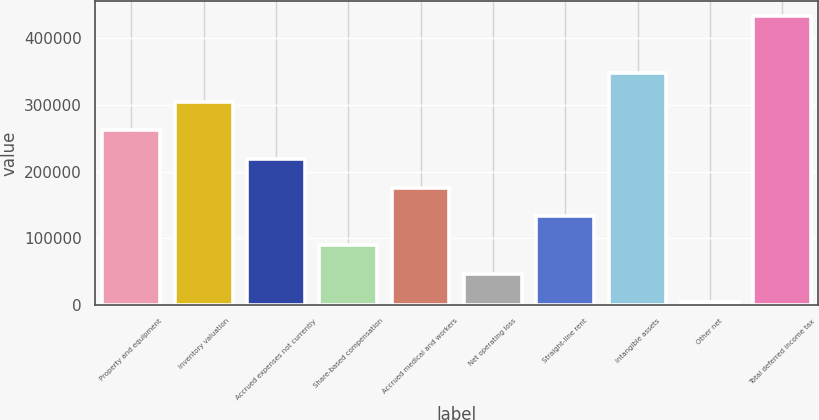<chart> <loc_0><loc_0><loc_500><loc_500><bar_chart><fcel>Property and equipment<fcel>Inventory valuation<fcel>Accrued expenses not currently<fcel>Share-based compensation<fcel>Accrued medical and workers<fcel>Net operating loss<fcel>Straight-line rent<fcel>Intangible assets<fcel>Other net<fcel>Total deferred income tax<nl><fcel>261714<fcel>304767<fcel>218662<fcel>89503.4<fcel>175609<fcel>46450.7<fcel>132556<fcel>347820<fcel>3398<fcel>433925<nl></chart> 